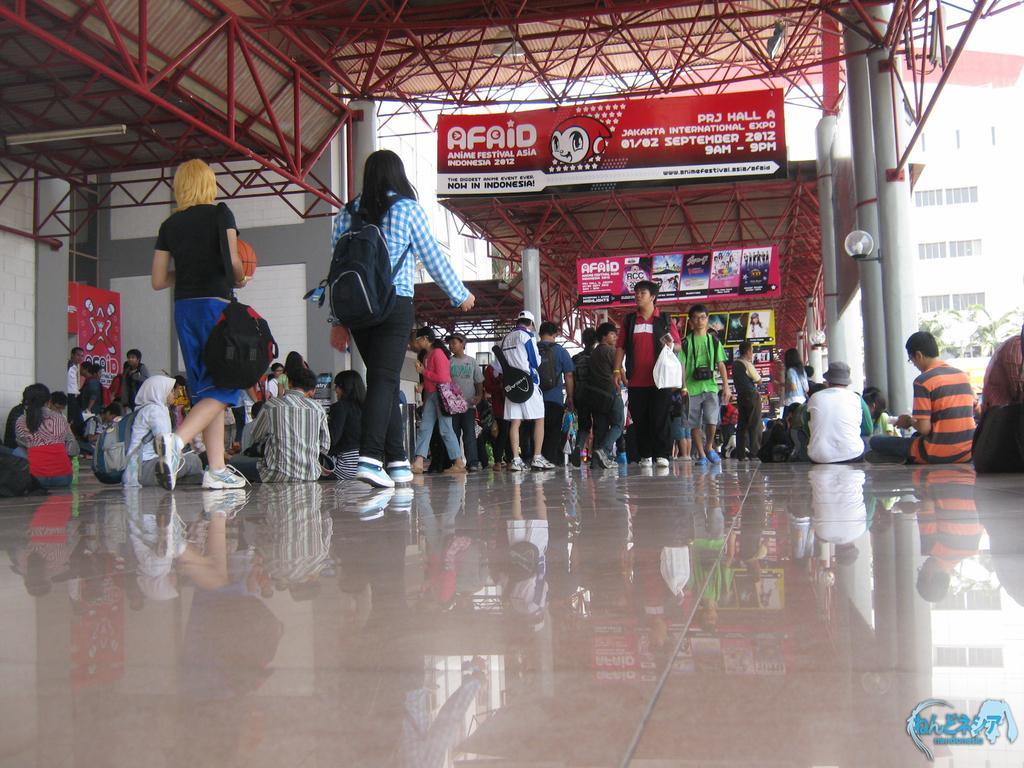Could you give a brief overview of what you see in this image? These two people are walking. Here we can see hoardings and people. Few people are sitting. Building with windows. Light is attached to this pole. This is an open shed. 